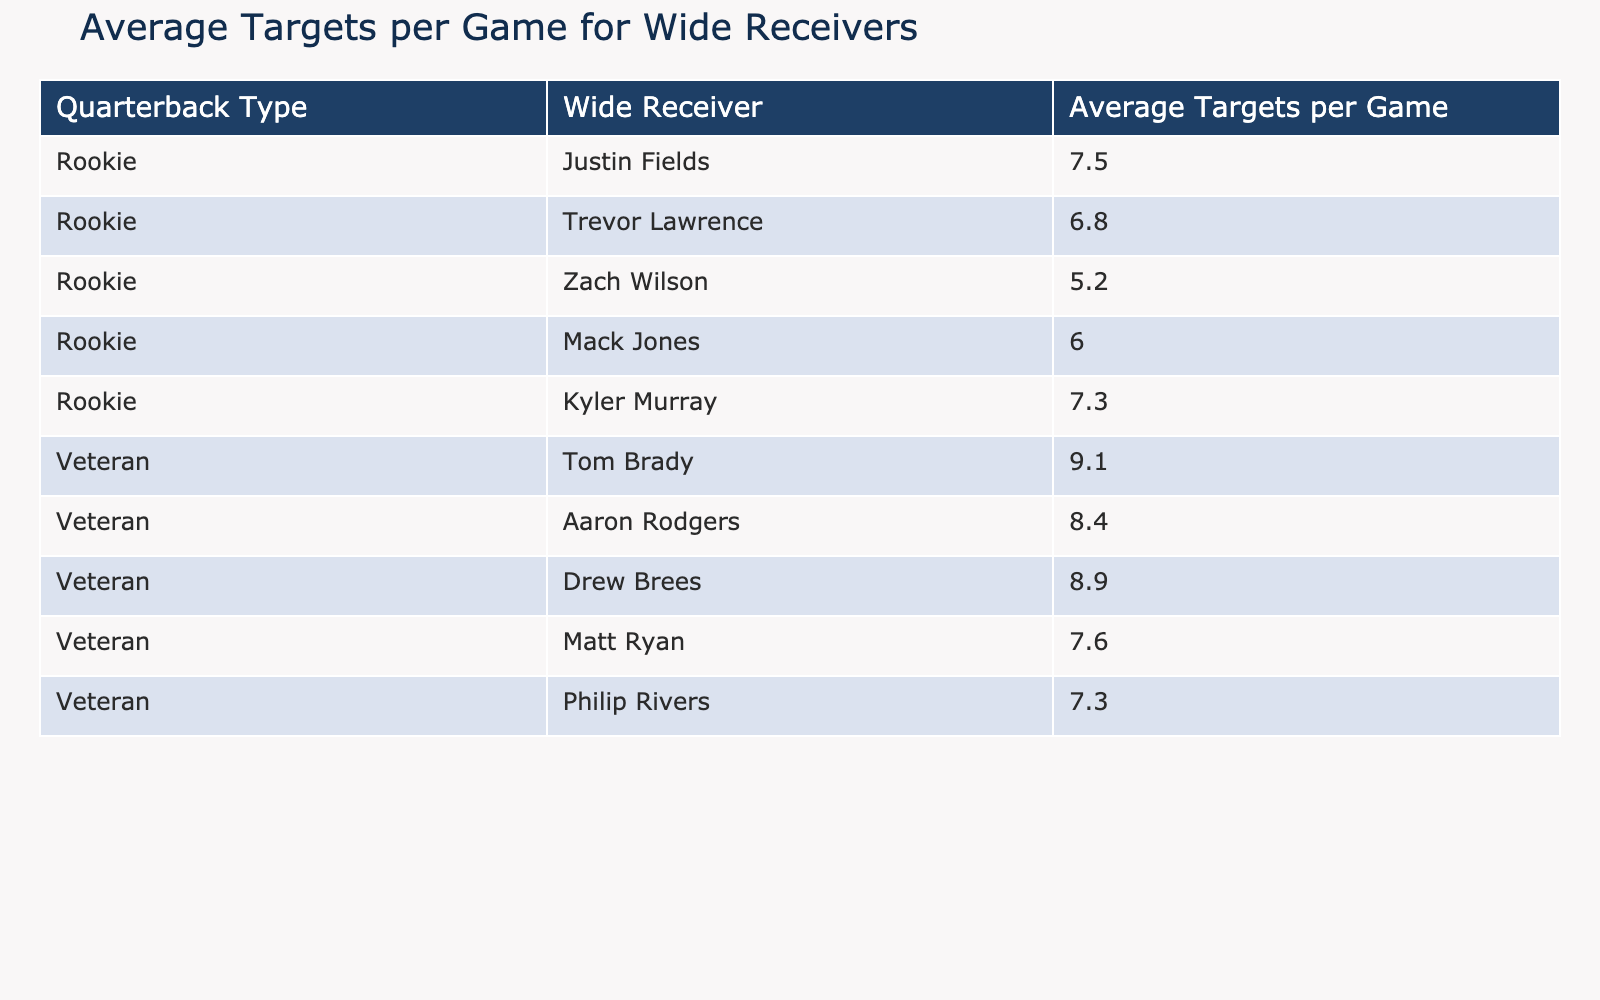What is the average targets per game for wide receivers with rookie quarterbacks? To find the average, we look at the rookies' targets: 7.5, 6.8, 5.2, 6.0, and 7.3. We sum these values (7.5 + 6.8 + 5.2 + 6.0 + 7.3 = 32.8) and divide by the number of rookies (5). Thus, 32.8/5 = 6.56.
Answer: 6.56 Which veteran quarterback has the highest average targets per game? We observe the veteran quarterbacks' targets: 9.1 (Tom Brady), 8.4 (Aaron Rodgers), 8.9 (Drew Brees), 7.6 (Matt Ryan), and 7.3 (Philip Rivers). The highest value is 9.1.
Answer: Tom Brady Is the average targets per game for rookie quarterbacks greater than that of veteran quarterbacks? The average targets for rookies is 6.56 and for veterans, we sum their targets (9.1 + 8.4 + 8.9 + 7.6 + 7.3 = 41.3) and divide by 5, which gives us 41.3/5 = 8.26. Since 6.56 is less than 8.26, the statement is false.
Answer: No What is the total number of average targets per game for all the quarterbacks listed? We find the total by summing all targets: (7.5 + 6.8 + 5.2 + 6.0 + 7.3 + 9.1 + 8.4 + 8.9 + 7.6 + 7.3) = 66.7.
Answer: 66.7 Which rookie quarterback has the lowest average targets per game? Looking at the rookie targets, we see 7.5, 6.8, 5.2, 6.0, and 7.3. The lowest value is 5.2, which belongs to Zach Wilson.
Answer: Zach Wilson Are there any rookie quarterbacks with an average of more than 7 targets per game? The rookie targets are 7.5, 6.8, 5.2, 6.0, and 7.3. Only Justin Fields (7.5) and Kyler Murray (7.3) exceed 7. Thus, the answer is yes.
Answer: Yes What is the difference in average targets per game between the highest rookie and the highest veteran quarterback? The highest rookie target is 7.5 (Justin Fields) and the highest veteran is 9.1 (Tom Brady). The difference is calculated as 9.1 - 7.5 = 1.6.
Answer: 1.6 What is the average of the average targets per game for the veterans? For veterans, the targets are 9.1, 8.4, 8.9, 7.6, and 7.3. Summing these (9.1 + 8.4 + 8.9 + 7.6 + 7.3 = 41.3) and averaging gives us 41.3/5 = 8.26.
Answer: 8.26 How many rookie quarterbacks have more than 6.5 average targets per game? Reviewing the rookie targets: 7.5, 6.8, 5.2, 6.0, and 7.3, we find that only Justin Fields (7.5), Trevor Lawrence (6.8), and Kyler Murray (7.3) are above 6.5. This totals three rookie quarterbacks.
Answer: 3 